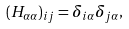Convert formula to latex. <formula><loc_0><loc_0><loc_500><loc_500>( { H } _ { \alpha \alpha } ) _ { i j } = \delta _ { i \alpha } \delta _ { j \alpha } ,</formula> 